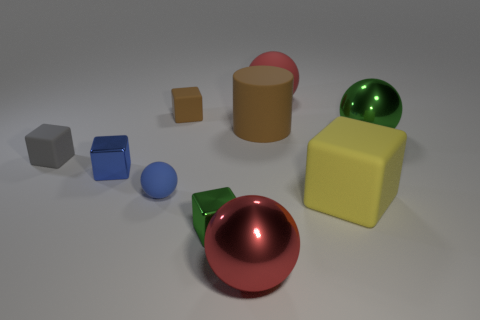Which object seems to be in the foreground? The red sphere is positioned in the foreground, drawing the viewer's attention due to its prominent placement and glossy finish.  What can you say about the lighting in this scene? The lighting appears to be neutral and diffused, casting soft shadows and highlighting the shapes without causing any harsh glare. It enhances the three-dimensionality of the objects. 